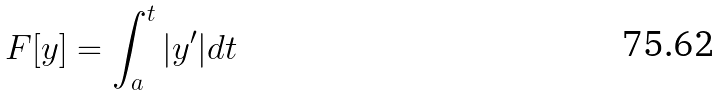Convert formula to latex. <formula><loc_0><loc_0><loc_500><loc_500>F [ y ] = \int _ { a } ^ { t } | y ^ { \prime } | d t</formula> 